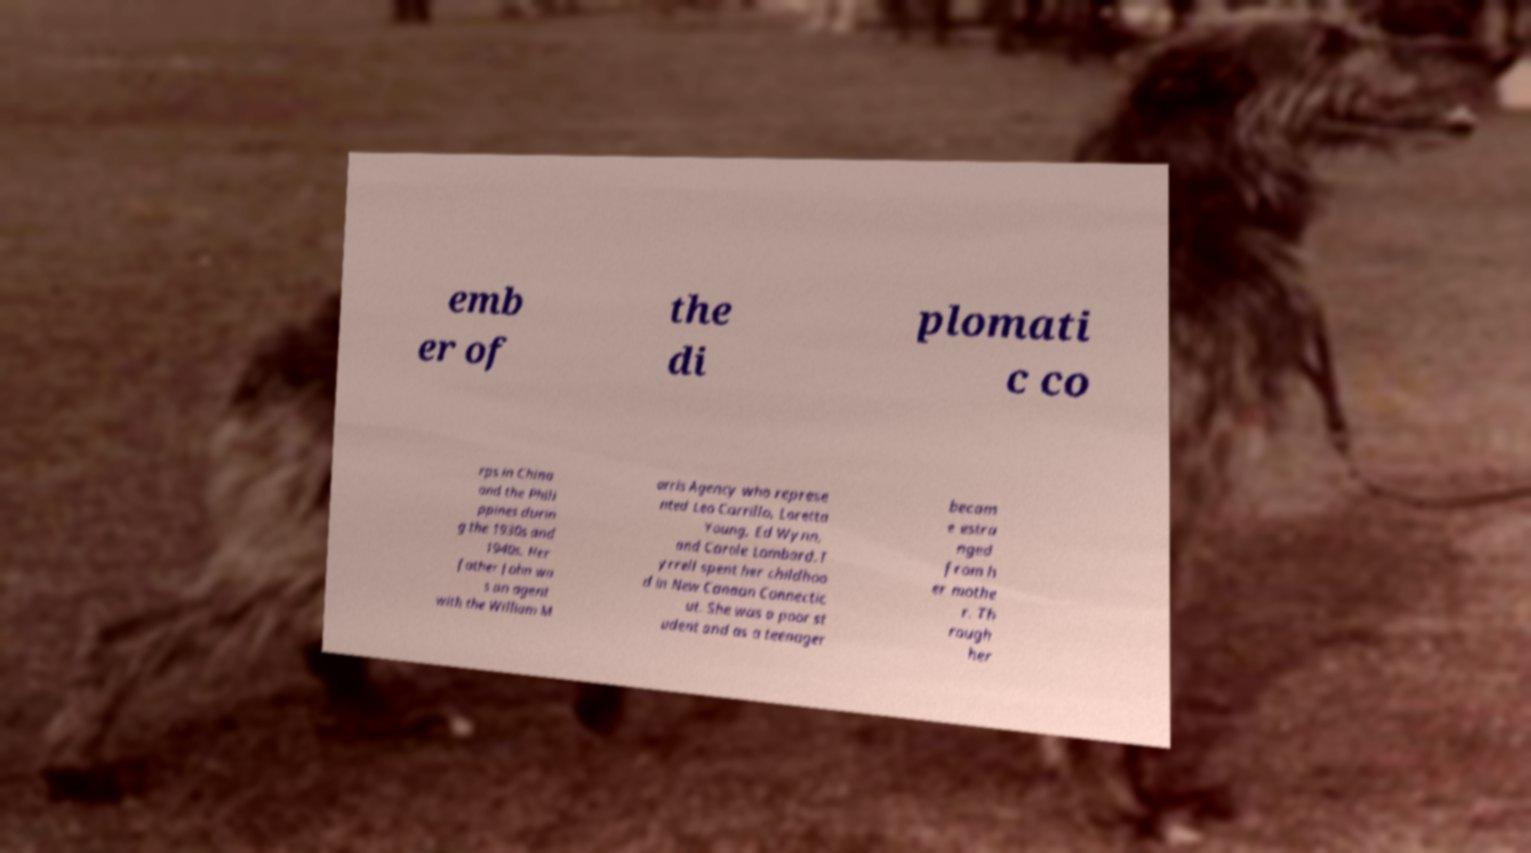Can you read and provide the text displayed in the image?This photo seems to have some interesting text. Can you extract and type it out for me? emb er of the di plomati c co rps in China and the Phili ppines durin g the 1930s and 1940s. Her father John wa s an agent with the William M orris Agency who represe nted Leo Carrillo, Loretta Young, Ed Wynn, and Carole Lombard.T yrrell spent her childhoo d in New Canaan Connectic ut. She was a poor st udent and as a teenager becam e estra nged from h er mothe r. Th rough her 